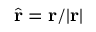<formula> <loc_0><loc_0><loc_500><loc_500>\hat { r } = r / | r |</formula> 